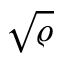<formula> <loc_0><loc_0><loc_500><loc_500>\sqrt { \varrho }</formula> 